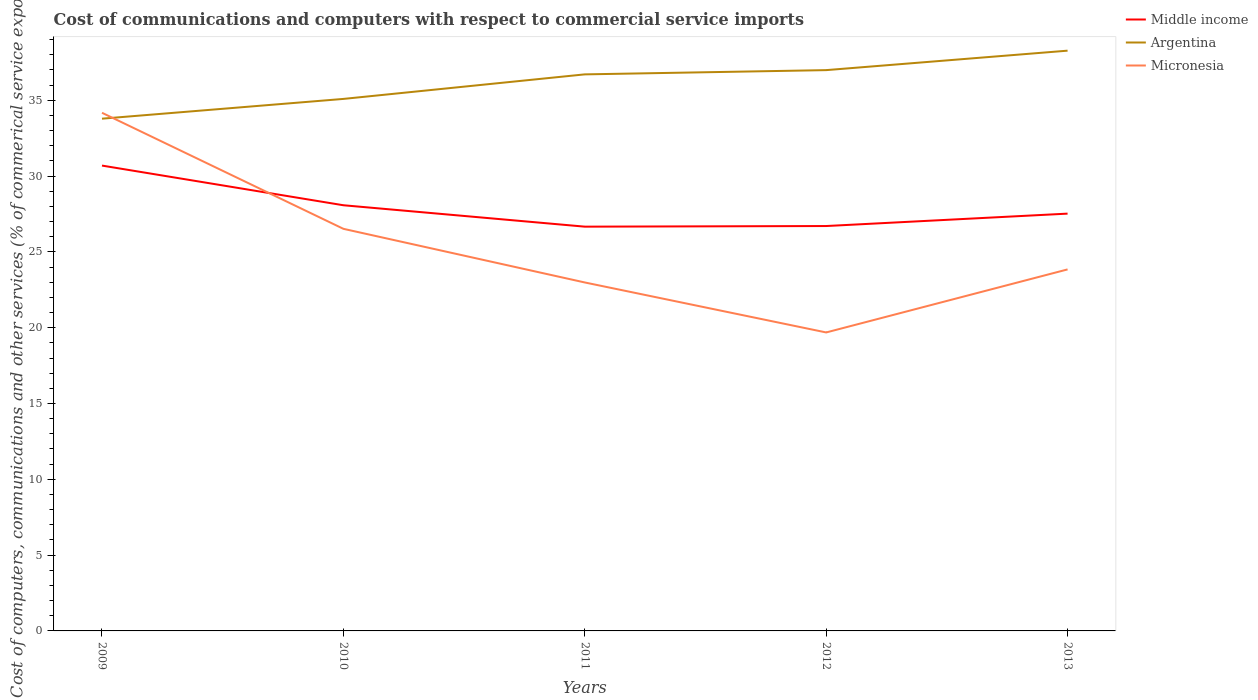Across all years, what is the maximum cost of communications and computers in Middle income?
Keep it short and to the point. 26.66. In which year was the cost of communications and computers in Middle income maximum?
Make the answer very short. 2011. What is the total cost of communications and computers in Micronesia in the graph?
Your response must be concise. 7.65. What is the difference between the highest and the second highest cost of communications and computers in Middle income?
Your answer should be compact. 4.03. Is the cost of communications and computers in Argentina strictly greater than the cost of communications and computers in Micronesia over the years?
Your answer should be very brief. No. Does the graph contain grids?
Keep it short and to the point. No. How many legend labels are there?
Make the answer very short. 3. What is the title of the graph?
Ensure brevity in your answer.  Cost of communications and computers with respect to commercial service imports. Does "Latvia" appear as one of the legend labels in the graph?
Provide a short and direct response. No. What is the label or title of the X-axis?
Make the answer very short. Years. What is the label or title of the Y-axis?
Make the answer very short. Cost of computers, communications and other services (% of commerical service exports). What is the Cost of computers, communications and other services (% of commerical service exports) in Middle income in 2009?
Your answer should be very brief. 30.69. What is the Cost of computers, communications and other services (% of commerical service exports) of Argentina in 2009?
Provide a succinct answer. 33.79. What is the Cost of computers, communications and other services (% of commerical service exports) of Micronesia in 2009?
Keep it short and to the point. 34.18. What is the Cost of computers, communications and other services (% of commerical service exports) in Middle income in 2010?
Provide a succinct answer. 28.08. What is the Cost of computers, communications and other services (% of commerical service exports) of Argentina in 2010?
Offer a very short reply. 35.09. What is the Cost of computers, communications and other services (% of commerical service exports) of Micronesia in 2010?
Provide a succinct answer. 26.52. What is the Cost of computers, communications and other services (% of commerical service exports) of Middle income in 2011?
Give a very brief answer. 26.66. What is the Cost of computers, communications and other services (% of commerical service exports) in Argentina in 2011?
Give a very brief answer. 36.71. What is the Cost of computers, communications and other services (% of commerical service exports) in Micronesia in 2011?
Provide a succinct answer. 22.98. What is the Cost of computers, communications and other services (% of commerical service exports) of Middle income in 2012?
Provide a short and direct response. 26.71. What is the Cost of computers, communications and other services (% of commerical service exports) of Argentina in 2012?
Your answer should be compact. 36.99. What is the Cost of computers, communications and other services (% of commerical service exports) of Micronesia in 2012?
Give a very brief answer. 19.69. What is the Cost of computers, communications and other services (% of commerical service exports) in Middle income in 2013?
Your response must be concise. 27.52. What is the Cost of computers, communications and other services (% of commerical service exports) of Argentina in 2013?
Give a very brief answer. 38.27. What is the Cost of computers, communications and other services (% of commerical service exports) in Micronesia in 2013?
Give a very brief answer. 23.84. Across all years, what is the maximum Cost of computers, communications and other services (% of commerical service exports) in Middle income?
Your response must be concise. 30.69. Across all years, what is the maximum Cost of computers, communications and other services (% of commerical service exports) of Argentina?
Your answer should be very brief. 38.27. Across all years, what is the maximum Cost of computers, communications and other services (% of commerical service exports) of Micronesia?
Make the answer very short. 34.18. Across all years, what is the minimum Cost of computers, communications and other services (% of commerical service exports) of Middle income?
Keep it short and to the point. 26.66. Across all years, what is the minimum Cost of computers, communications and other services (% of commerical service exports) of Argentina?
Provide a succinct answer. 33.79. Across all years, what is the minimum Cost of computers, communications and other services (% of commerical service exports) of Micronesia?
Provide a succinct answer. 19.69. What is the total Cost of computers, communications and other services (% of commerical service exports) in Middle income in the graph?
Provide a succinct answer. 139.66. What is the total Cost of computers, communications and other services (% of commerical service exports) of Argentina in the graph?
Your answer should be compact. 180.85. What is the total Cost of computers, communications and other services (% of commerical service exports) of Micronesia in the graph?
Provide a succinct answer. 127.21. What is the difference between the Cost of computers, communications and other services (% of commerical service exports) in Middle income in 2009 and that in 2010?
Your answer should be very brief. 2.62. What is the difference between the Cost of computers, communications and other services (% of commerical service exports) in Argentina in 2009 and that in 2010?
Keep it short and to the point. -1.3. What is the difference between the Cost of computers, communications and other services (% of commerical service exports) in Micronesia in 2009 and that in 2010?
Provide a short and direct response. 7.65. What is the difference between the Cost of computers, communications and other services (% of commerical service exports) of Middle income in 2009 and that in 2011?
Your answer should be very brief. 4.03. What is the difference between the Cost of computers, communications and other services (% of commerical service exports) of Argentina in 2009 and that in 2011?
Provide a short and direct response. -2.92. What is the difference between the Cost of computers, communications and other services (% of commerical service exports) in Micronesia in 2009 and that in 2011?
Keep it short and to the point. 11.19. What is the difference between the Cost of computers, communications and other services (% of commerical service exports) of Middle income in 2009 and that in 2012?
Provide a short and direct response. 3.99. What is the difference between the Cost of computers, communications and other services (% of commerical service exports) of Argentina in 2009 and that in 2012?
Give a very brief answer. -3.2. What is the difference between the Cost of computers, communications and other services (% of commerical service exports) in Micronesia in 2009 and that in 2012?
Your response must be concise. 14.49. What is the difference between the Cost of computers, communications and other services (% of commerical service exports) of Middle income in 2009 and that in 2013?
Offer a very short reply. 3.17. What is the difference between the Cost of computers, communications and other services (% of commerical service exports) of Argentina in 2009 and that in 2013?
Make the answer very short. -4.49. What is the difference between the Cost of computers, communications and other services (% of commerical service exports) in Micronesia in 2009 and that in 2013?
Offer a very short reply. 10.33. What is the difference between the Cost of computers, communications and other services (% of commerical service exports) of Middle income in 2010 and that in 2011?
Offer a very short reply. 1.41. What is the difference between the Cost of computers, communications and other services (% of commerical service exports) of Argentina in 2010 and that in 2011?
Make the answer very short. -1.62. What is the difference between the Cost of computers, communications and other services (% of commerical service exports) of Micronesia in 2010 and that in 2011?
Your answer should be very brief. 3.54. What is the difference between the Cost of computers, communications and other services (% of commerical service exports) in Middle income in 2010 and that in 2012?
Make the answer very short. 1.37. What is the difference between the Cost of computers, communications and other services (% of commerical service exports) in Argentina in 2010 and that in 2012?
Provide a succinct answer. -1.9. What is the difference between the Cost of computers, communications and other services (% of commerical service exports) in Micronesia in 2010 and that in 2012?
Your answer should be compact. 6.83. What is the difference between the Cost of computers, communications and other services (% of commerical service exports) of Middle income in 2010 and that in 2013?
Offer a terse response. 0.55. What is the difference between the Cost of computers, communications and other services (% of commerical service exports) in Argentina in 2010 and that in 2013?
Your answer should be compact. -3.18. What is the difference between the Cost of computers, communications and other services (% of commerical service exports) of Micronesia in 2010 and that in 2013?
Your answer should be very brief. 2.68. What is the difference between the Cost of computers, communications and other services (% of commerical service exports) in Middle income in 2011 and that in 2012?
Your answer should be compact. -0.04. What is the difference between the Cost of computers, communications and other services (% of commerical service exports) in Argentina in 2011 and that in 2012?
Provide a succinct answer. -0.28. What is the difference between the Cost of computers, communications and other services (% of commerical service exports) in Micronesia in 2011 and that in 2012?
Provide a succinct answer. 3.3. What is the difference between the Cost of computers, communications and other services (% of commerical service exports) in Middle income in 2011 and that in 2013?
Your answer should be very brief. -0.86. What is the difference between the Cost of computers, communications and other services (% of commerical service exports) in Argentina in 2011 and that in 2013?
Offer a very short reply. -1.56. What is the difference between the Cost of computers, communications and other services (% of commerical service exports) of Micronesia in 2011 and that in 2013?
Ensure brevity in your answer.  -0.86. What is the difference between the Cost of computers, communications and other services (% of commerical service exports) in Middle income in 2012 and that in 2013?
Ensure brevity in your answer.  -0.82. What is the difference between the Cost of computers, communications and other services (% of commerical service exports) of Argentina in 2012 and that in 2013?
Ensure brevity in your answer.  -1.28. What is the difference between the Cost of computers, communications and other services (% of commerical service exports) of Micronesia in 2012 and that in 2013?
Give a very brief answer. -4.16. What is the difference between the Cost of computers, communications and other services (% of commerical service exports) of Middle income in 2009 and the Cost of computers, communications and other services (% of commerical service exports) of Argentina in 2010?
Your response must be concise. -4.4. What is the difference between the Cost of computers, communications and other services (% of commerical service exports) in Middle income in 2009 and the Cost of computers, communications and other services (% of commerical service exports) in Micronesia in 2010?
Your answer should be compact. 4.17. What is the difference between the Cost of computers, communications and other services (% of commerical service exports) of Argentina in 2009 and the Cost of computers, communications and other services (% of commerical service exports) of Micronesia in 2010?
Your answer should be very brief. 7.27. What is the difference between the Cost of computers, communications and other services (% of commerical service exports) of Middle income in 2009 and the Cost of computers, communications and other services (% of commerical service exports) of Argentina in 2011?
Offer a terse response. -6.02. What is the difference between the Cost of computers, communications and other services (% of commerical service exports) of Middle income in 2009 and the Cost of computers, communications and other services (% of commerical service exports) of Micronesia in 2011?
Ensure brevity in your answer.  7.71. What is the difference between the Cost of computers, communications and other services (% of commerical service exports) in Argentina in 2009 and the Cost of computers, communications and other services (% of commerical service exports) in Micronesia in 2011?
Your response must be concise. 10.8. What is the difference between the Cost of computers, communications and other services (% of commerical service exports) in Middle income in 2009 and the Cost of computers, communications and other services (% of commerical service exports) in Argentina in 2012?
Provide a succinct answer. -6.3. What is the difference between the Cost of computers, communications and other services (% of commerical service exports) in Middle income in 2009 and the Cost of computers, communications and other services (% of commerical service exports) in Micronesia in 2012?
Ensure brevity in your answer.  11.01. What is the difference between the Cost of computers, communications and other services (% of commerical service exports) in Argentina in 2009 and the Cost of computers, communications and other services (% of commerical service exports) in Micronesia in 2012?
Provide a succinct answer. 14.1. What is the difference between the Cost of computers, communications and other services (% of commerical service exports) in Middle income in 2009 and the Cost of computers, communications and other services (% of commerical service exports) in Argentina in 2013?
Offer a very short reply. -7.58. What is the difference between the Cost of computers, communications and other services (% of commerical service exports) of Middle income in 2009 and the Cost of computers, communications and other services (% of commerical service exports) of Micronesia in 2013?
Ensure brevity in your answer.  6.85. What is the difference between the Cost of computers, communications and other services (% of commerical service exports) of Argentina in 2009 and the Cost of computers, communications and other services (% of commerical service exports) of Micronesia in 2013?
Give a very brief answer. 9.94. What is the difference between the Cost of computers, communications and other services (% of commerical service exports) of Middle income in 2010 and the Cost of computers, communications and other services (% of commerical service exports) of Argentina in 2011?
Ensure brevity in your answer.  -8.63. What is the difference between the Cost of computers, communications and other services (% of commerical service exports) of Middle income in 2010 and the Cost of computers, communications and other services (% of commerical service exports) of Micronesia in 2011?
Offer a terse response. 5.09. What is the difference between the Cost of computers, communications and other services (% of commerical service exports) of Argentina in 2010 and the Cost of computers, communications and other services (% of commerical service exports) of Micronesia in 2011?
Make the answer very short. 12.11. What is the difference between the Cost of computers, communications and other services (% of commerical service exports) in Middle income in 2010 and the Cost of computers, communications and other services (% of commerical service exports) in Argentina in 2012?
Your response must be concise. -8.91. What is the difference between the Cost of computers, communications and other services (% of commerical service exports) in Middle income in 2010 and the Cost of computers, communications and other services (% of commerical service exports) in Micronesia in 2012?
Give a very brief answer. 8.39. What is the difference between the Cost of computers, communications and other services (% of commerical service exports) of Argentina in 2010 and the Cost of computers, communications and other services (% of commerical service exports) of Micronesia in 2012?
Your response must be concise. 15.4. What is the difference between the Cost of computers, communications and other services (% of commerical service exports) of Middle income in 2010 and the Cost of computers, communications and other services (% of commerical service exports) of Argentina in 2013?
Make the answer very short. -10.2. What is the difference between the Cost of computers, communications and other services (% of commerical service exports) of Middle income in 2010 and the Cost of computers, communications and other services (% of commerical service exports) of Micronesia in 2013?
Your response must be concise. 4.23. What is the difference between the Cost of computers, communications and other services (% of commerical service exports) of Argentina in 2010 and the Cost of computers, communications and other services (% of commerical service exports) of Micronesia in 2013?
Make the answer very short. 11.25. What is the difference between the Cost of computers, communications and other services (% of commerical service exports) in Middle income in 2011 and the Cost of computers, communications and other services (% of commerical service exports) in Argentina in 2012?
Offer a terse response. -10.32. What is the difference between the Cost of computers, communications and other services (% of commerical service exports) in Middle income in 2011 and the Cost of computers, communications and other services (% of commerical service exports) in Micronesia in 2012?
Provide a succinct answer. 6.98. What is the difference between the Cost of computers, communications and other services (% of commerical service exports) in Argentina in 2011 and the Cost of computers, communications and other services (% of commerical service exports) in Micronesia in 2012?
Give a very brief answer. 17.02. What is the difference between the Cost of computers, communications and other services (% of commerical service exports) in Middle income in 2011 and the Cost of computers, communications and other services (% of commerical service exports) in Argentina in 2013?
Offer a terse response. -11.61. What is the difference between the Cost of computers, communications and other services (% of commerical service exports) of Middle income in 2011 and the Cost of computers, communications and other services (% of commerical service exports) of Micronesia in 2013?
Offer a terse response. 2.82. What is the difference between the Cost of computers, communications and other services (% of commerical service exports) in Argentina in 2011 and the Cost of computers, communications and other services (% of commerical service exports) in Micronesia in 2013?
Give a very brief answer. 12.86. What is the difference between the Cost of computers, communications and other services (% of commerical service exports) of Middle income in 2012 and the Cost of computers, communications and other services (% of commerical service exports) of Argentina in 2013?
Keep it short and to the point. -11.57. What is the difference between the Cost of computers, communications and other services (% of commerical service exports) in Middle income in 2012 and the Cost of computers, communications and other services (% of commerical service exports) in Micronesia in 2013?
Your answer should be compact. 2.86. What is the difference between the Cost of computers, communications and other services (% of commerical service exports) in Argentina in 2012 and the Cost of computers, communications and other services (% of commerical service exports) in Micronesia in 2013?
Provide a short and direct response. 13.14. What is the average Cost of computers, communications and other services (% of commerical service exports) of Middle income per year?
Your answer should be compact. 27.93. What is the average Cost of computers, communications and other services (% of commerical service exports) in Argentina per year?
Make the answer very short. 36.17. What is the average Cost of computers, communications and other services (% of commerical service exports) of Micronesia per year?
Ensure brevity in your answer.  25.44. In the year 2009, what is the difference between the Cost of computers, communications and other services (% of commerical service exports) in Middle income and Cost of computers, communications and other services (% of commerical service exports) in Argentina?
Provide a short and direct response. -3.09. In the year 2009, what is the difference between the Cost of computers, communications and other services (% of commerical service exports) of Middle income and Cost of computers, communications and other services (% of commerical service exports) of Micronesia?
Keep it short and to the point. -3.48. In the year 2009, what is the difference between the Cost of computers, communications and other services (% of commerical service exports) of Argentina and Cost of computers, communications and other services (% of commerical service exports) of Micronesia?
Your response must be concise. -0.39. In the year 2010, what is the difference between the Cost of computers, communications and other services (% of commerical service exports) of Middle income and Cost of computers, communications and other services (% of commerical service exports) of Argentina?
Keep it short and to the point. -7.01. In the year 2010, what is the difference between the Cost of computers, communications and other services (% of commerical service exports) in Middle income and Cost of computers, communications and other services (% of commerical service exports) in Micronesia?
Offer a very short reply. 1.55. In the year 2010, what is the difference between the Cost of computers, communications and other services (% of commerical service exports) of Argentina and Cost of computers, communications and other services (% of commerical service exports) of Micronesia?
Ensure brevity in your answer.  8.57. In the year 2011, what is the difference between the Cost of computers, communications and other services (% of commerical service exports) of Middle income and Cost of computers, communications and other services (% of commerical service exports) of Argentina?
Offer a terse response. -10.04. In the year 2011, what is the difference between the Cost of computers, communications and other services (% of commerical service exports) in Middle income and Cost of computers, communications and other services (% of commerical service exports) in Micronesia?
Your answer should be very brief. 3.68. In the year 2011, what is the difference between the Cost of computers, communications and other services (% of commerical service exports) in Argentina and Cost of computers, communications and other services (% of commerical service exports) in Micronesia?
Provide a succinct answer. 13.73. In the year 2012, what is the difference between the Cost of computers, communications and other services (% of commerical service exports) of Middle income and Cost of computers, communications and other services (% of commerical service exports) of Argentina?
Your answer should be compact. -10.28. In the year 2012, what is the difference between the Cost of computers, communications and other services (% of commerical service exports) in Middle income and Cost of computers, communications and other services (% of commerical service exports) in Micronesia?
Your answer should be very brief. 7.02. In the year 2012, what is the difference between the Cost of computers, communications and other services (% of commerical service exports) in Argentina and Cost of computers, communications and other services (% of commerical service exports) in Micronesia?
Offer a very short reply. 17.3. In the year 2013, what is the difference between the Cost of computers, communications and other services (% of commerical service exports) in Middle income and Cost of computers, communications and other services (% of commerical service exports) in Argentina?
Give a very brief answer. -10.75. In the year 2013, what is the difference between the Cost of computers, communications and other services (% of commerical service exports) in Middle income and Cost of computers, communications and other services (% of commerical service exports) in Micronesia?
Keep it short and to the point. 3.68. In the year 2013, what is the difference between the Cost of computers, communications and other services (% of commerical service exports) of Argentina and Cost of computers, communications and other services (% of commerical service exports) of Micronesia?
Offer a terse response. 14.43. What is the ratio of the Cost of computers, communications and other services (% of commerical service exports) of Middle income in 2009 to that in 2010?
Keep it short and to the point. 1.09. What is the ratio of the Cost of computers, communications and other services (% of commerical service exports) of Argentina in 2009 to that in 2010?
Offer a terse response. 0.96. What is the ratio of the Cost of computers, communications and other services (% of commerical service exports) in Micronesia in 2009 to that in 2010?
Offer a terse response. 1.29. What is the ratio of the Cost of computers, communications and other services (% of commerical service exports) of Middle income in 2009 to that in 2011?
Your answer should be very brief. 1.15. What is the ratio of the Cost of computers, communications and other services (% of commerical service exports) in Argentina in 2009 to that in 2011?
Ensure brevity in your answer.  0.92. What is the ratio of the Cost of computers, communications and other services (% of commerical service exports) of Micronesia in 2009 to that in 2011?
Offer a very short reply. 1.49. What is the ratio of the Cost of computers, communications and other services (% of commerical service exports) in Middle income in 2009 to that in 2012?
Provide a short and direct response. 1.15. What is the ratio of the Cost of computers, communications and other services (% of commerical service exports) in Argentina in 2009 to that in 2012?
Provide a succinct answer. 0.91. What is the ratio of the Cost of computers, communications and other services (% of commerical service exports) of Micronesia in 2009 to that in 2012?
Make the answer very short. 1.74. What is the ratio of the Cost of computers, communications and other services (% of commerical service exports) of Middle income in 2009 to that in 2013?
Your answer should be compact. 1.12. What is the ratio of the Cost of computers, communications and other services (% of commerical service exports) in Argentina in 2009 to that in 2013?
Provide a succinct answer. 0.88. What is the ratio of the Cost of computers, communications and other services (% of commerical service exports) of Micronesia in 2009 to that in 2013?
Your answer should be very brief. 1.43. What is the ratio of the Cost of computers, communications and other services (% of commerical service exports) of Middle income in 2010 to that in 2011?
Give a very brief answer. 1.05. What is the ratio of the Cost of computers, communications and other services (% of commerical service exports) of Argentina in 2010 to that in 2011?
Your answer should be compact. 0.96. What is the ratio of the Cost of computers, communications and other services (% of commerical service exports) of Micronesia in 2010 to that in 2011?
Ensure brevity in your answer.  1.15. What is the ratio of the Cost of computers, communications and other services (% of commerical service exports) of Middle income in 2010 to that in 2012?
Give a very brief answer. 1.05. What is the ratio of the Cost of computers, communications and other services (% of commerical service exports) of Argentina in 2010 to that in 2012?
Your answer should be compact. 0.95. What is the ratio of the Cost of computers, communications and other services (% of commerical service exports) of Micronesia in 2010 to that in 2012?
Your response must be concise. 1.35. What is the ratio of the Cost of computers, communications and other services (% of commerical service exports) in Middle income in 2010 to that in 2013?
Provide a short and direct response. 1.02. What is the ratio of the Cost of computers, communications and other services (% of commerical service exports) of Argentina in 2010 to that in 2013?
Your answer should be compact. 0.92. What is the ratio of the Cost of computers, communications and other services (% of commerical service exports) of Micronesia in 2010 to that in 2013?
Your answer should be compact. 1.11. What is the ratio of the Cost of computers, communications and other services (% of commerical service exports) in Middle income in 2011 to that in 2012?
Offer a terse response. 1. What is the ratio of the Cost of computers, communications and other services (% of commerical service exports) of Micronesia in 2011 to that in 2012?
Make the answer very short. 1.17. What is the ratio of the Cost of computers, communications and other services (% of commerical service exports) of Middle income in 2011 to that in 2013?
Offer a very short reply. 0.97. What is the ratio of the Cost of computers, communications and other services (% of commerical service exports) in Argentina in 2011 to that in 2013?
Make the answer very short. 0.96. What is the ratio of the Cost of computers, communications and other services (% of commerical service exports) of Micronesia in 2011 to that in 2013?
Your answer should be very brief. 0.96. What is the ratio of the Cost of computers, communications and other services (% of commerical service exports) of Middle income in 2012 to that in 2013?
Your response must be concise. 0.97. What is the ratio of the Cost of computers, communications and other services (% of commerical service exports) of Argentina in 2012 to that in 2013?
Give a very brief answer. 0.97. What is the ratio of the Cost of computers, communications and other services (% of commerical service exports) of Micronesia in 2012 to that in 2013?
Your response must be concise. 0.83. What is the difference between the highest and the second highest Cost of computers, communications and other services (% of commerical service exports) in Middle income?
Give a very brief answer. 2.62. What is the difference between the highest and the second highest Cost of computers, communications and other services (% of commerical service exports) of Argentina?
Give a very brief answer. 1.28. What is the difference between the highest and the second highest Cost of computers, communications and other services (% of commerical service exports) of Micronesia?
Give a very brief answer. 7.65. What is the difference between the highest and the lowest Cost of computers, communications and other services (% of commerical service exports) of Middle income?
Your answer should be very brief. 4.03. What is the difference between the highest and the lowest Cost of computers, communications and other services (% of commerical service exports) of Argentina?
Your response must be concise. 4.49. What is the difference between the highest and the lowest Cost of computers, communications and other services (% of commerical service exports) in Micronesia?
Give a very brief answer. 14.49. 